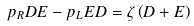<formula> <loc_0><loc_0><loc_500><loc_500>p _ { R } D E - p _ { L } E D = \zeta \left ( D + E \right )</formula> 